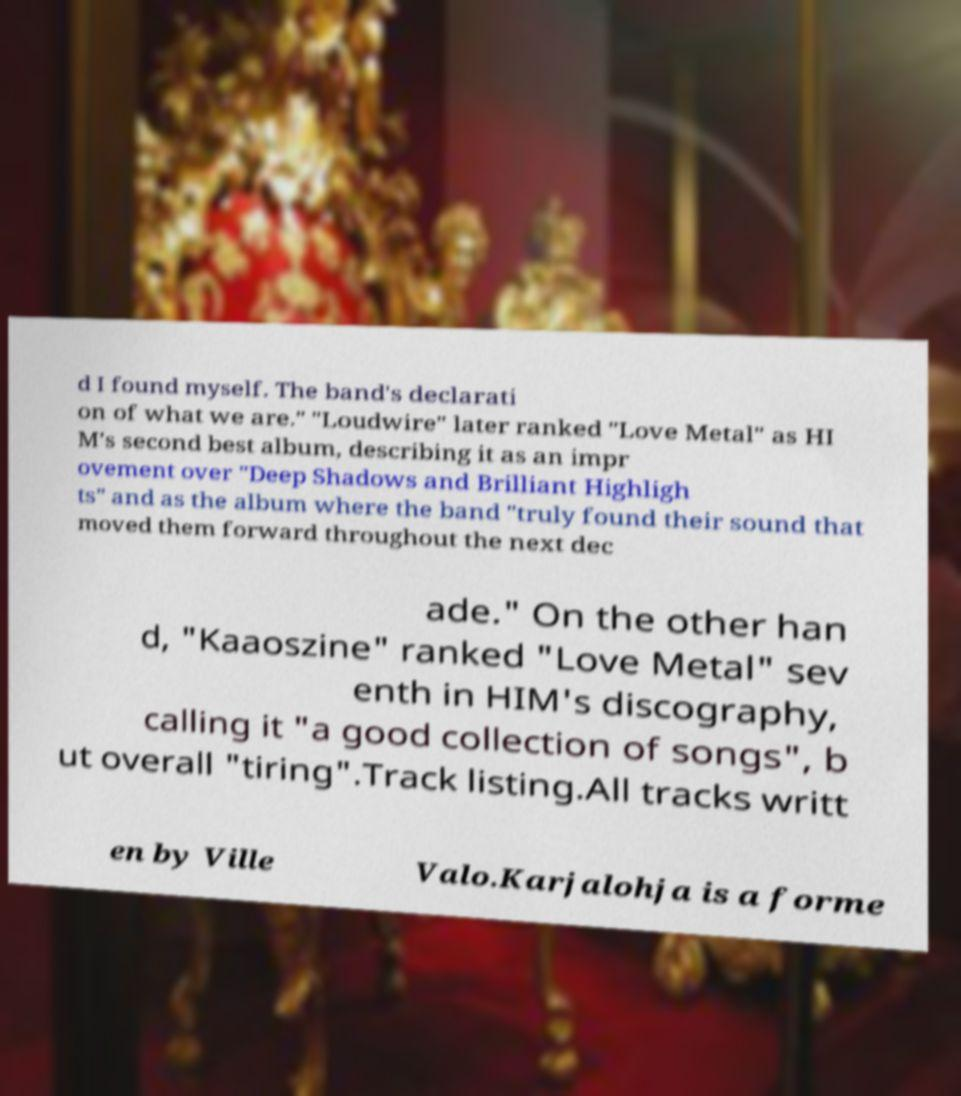I need the written content from this picture converted into text. Can you do that? d I found myself. The band's declarati on of what we are." "Loudwire" later ranked "Love Metal" as HI M's second best album, describing it as an impr ovement over "Deep Shadows and Brilliant Highligh ts" and as the album where the band "truly found their sound that moved them forward throughout the next dec ade." On the other han d, "Kaaoszine" ranked "Love Metal" sev enth in HIM's discography, calling it "a good collection of songs", b ut overall "tiring".Track listing.All tracks writt en by Ville Valo.Karjalohja is a forme 